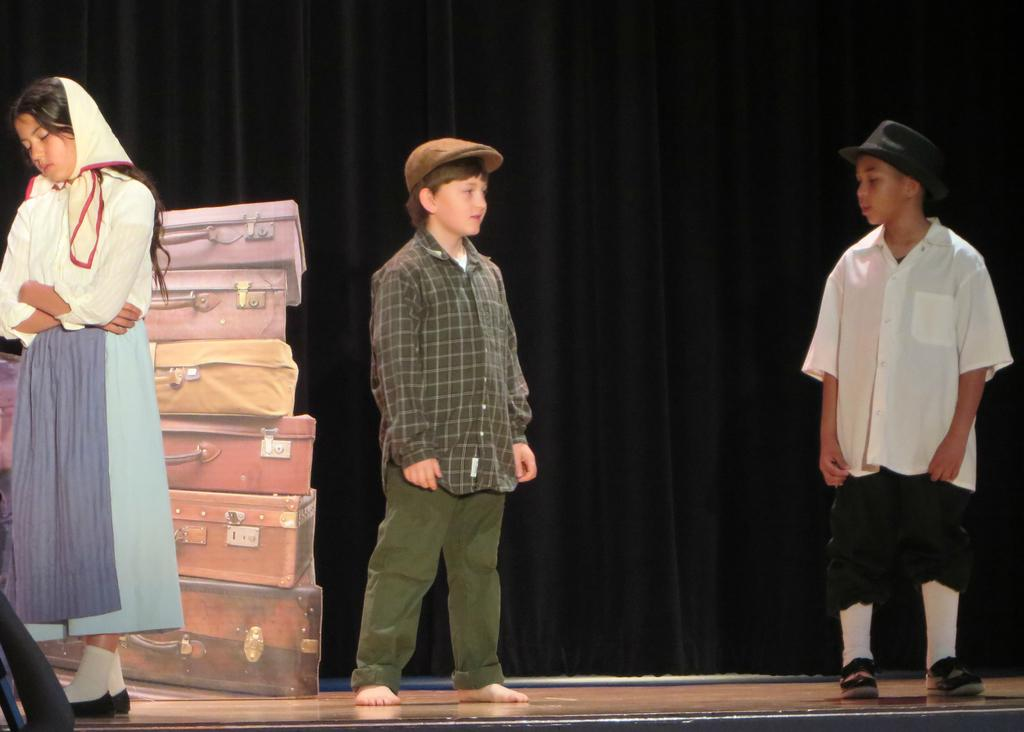Who is present in the image? There is a lady and two boys in the image. What are the lady and boys doing? The lady and boys are standing. What might indicate that they are about to travel or have just returned from a trip? The presence of luggage visible in the image suggests that they are about to travel or have just returned from a trip. What can be seen in the background of the image? There is a cloth hanging in the background of the image. What type of pies are being served on the vessel in the image? There is no vessel or pies present in the image. What discovery was made by the lady and boys in the image? There is no indication of a discovery made by the lady and boys in the image. 